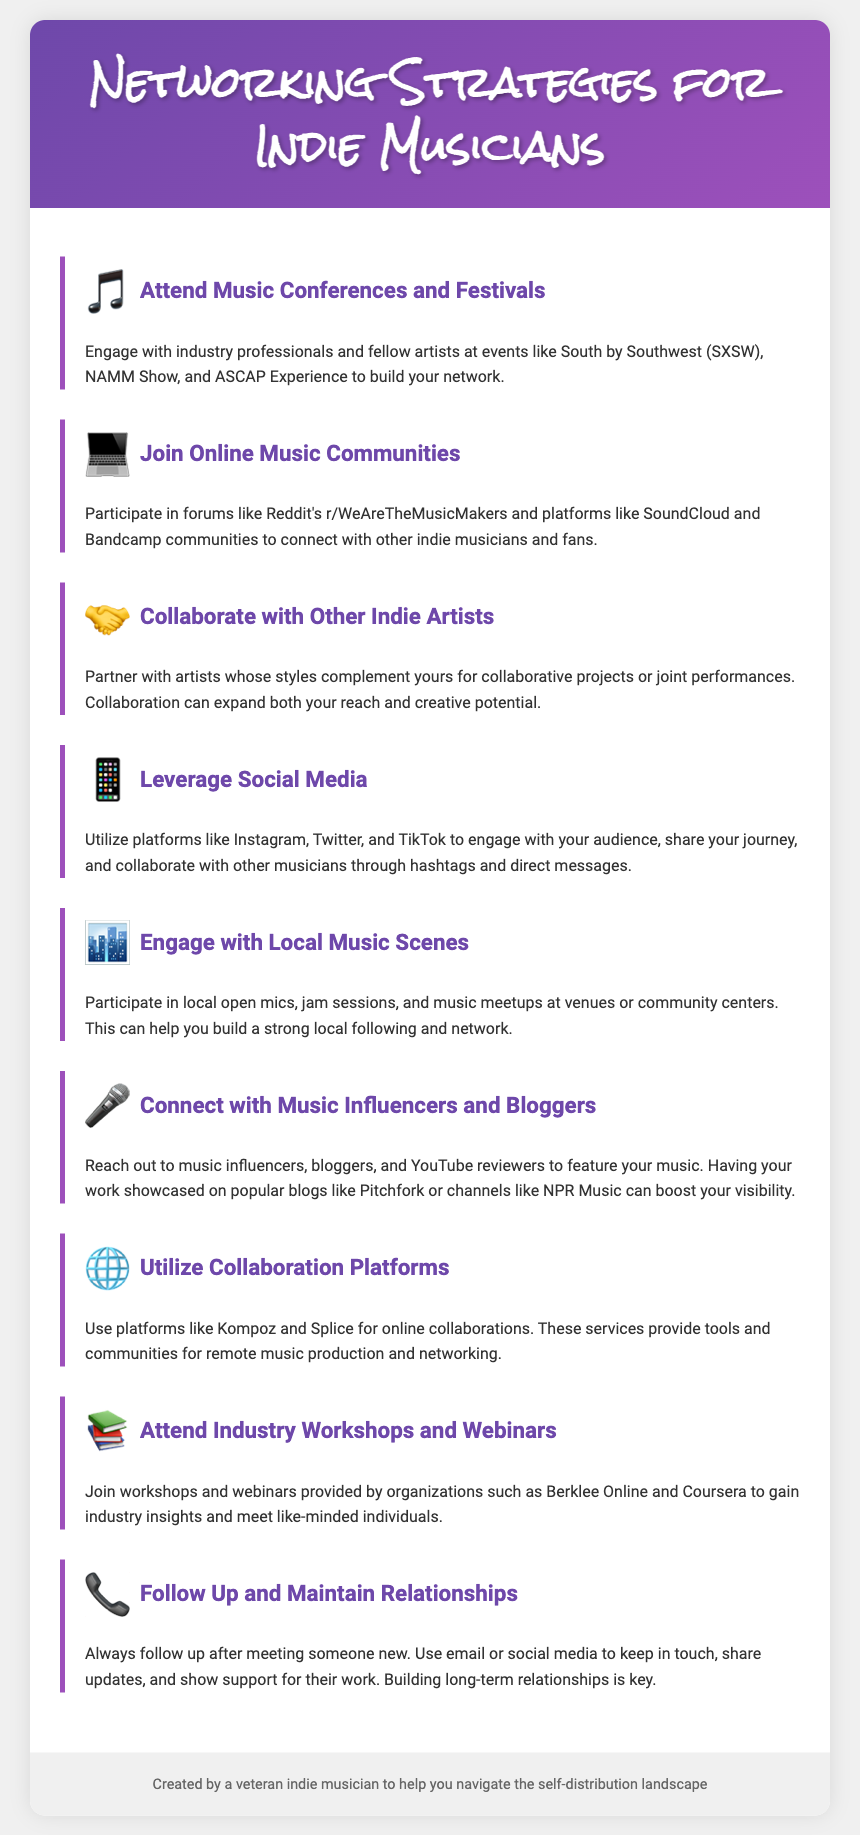What is one major event to attend for networking? The document mentions music conferences and festivals like South by Southwest (SXSW) for networking with industry professionals and fellow artists.
Answer: South by Southwest (SXSW) Which online community is suggested for indie musicians? The document lists Reddit's r/WeAreTheMusicMakers as a platform for connecting with other musicians and fans online.
Answer: Reddit's r/WeAreTheMusicMakers What is a suggested way to build local connections? Engaging with the local music scene through open mics and jam sessions is recommended for building a local following.
Answer: Open mics and jam sessions Which platforms can be used for collaboration online? The document suggests using Kompoz and Splice for online collaborations in music production.
Answer: Kompoz and Splice What is important to do after meeting someone new? The document emphasizes the importance of following up and maintaining relationships through email or social media after meeting someone.
Answer: Follow up How can you connect with music influencers? Reaching out to music influencers, bloggers, and YouTube reviewers is recommended for showcasing your music.
Answer: Reach out to music influencers What kind of events can provide industry insights? Workshops and webinars provided by organizations like Berklee Online and Coursera are listed as events that can provide valuable industry insights.
Answer: Workshops and webinars What should you use to engage your audience on social media? The document advises utilizing platforms like Instagram, Twitter, and TikTok to engage with your audience.
Answer: Instagram, Twitter, and TikTok What is the potential benefit of collaborating with other artists? Collaborating with other indie artists can expand both your reach and creative potential, according to the document.
Answer: Expand reach and creative potential 